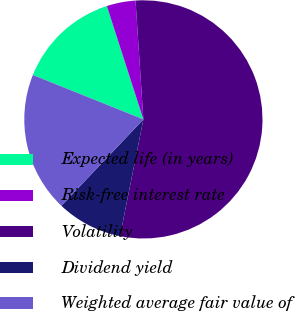<chart> <loc_0><loc_0><loc_500><loc_500><pie_chart><fcel>Expected life (in years)<fcel>Risk-free interest rate<fcel>Volatility<fcel>Dividend yield<fcel>Weighted average fair value of<nl><fcel>13.96%<fcel>3.91%<fcel>54.2%<fcel>8.94%<fcel>18.99%<nl></chart> 